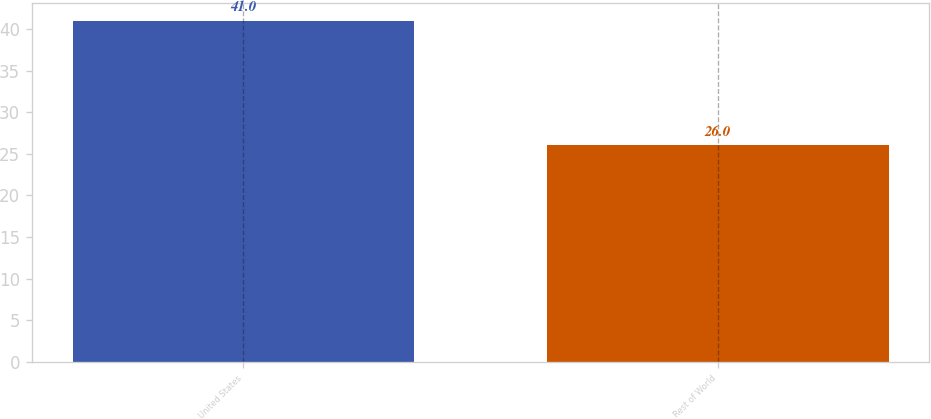Convert chart. <chart><loc_0><loc_0><loc_500><loc_500><bar_chart><fcel>United States<fcel>Rest of World<nl><fcel>41<fcel>26<nl></chart> 